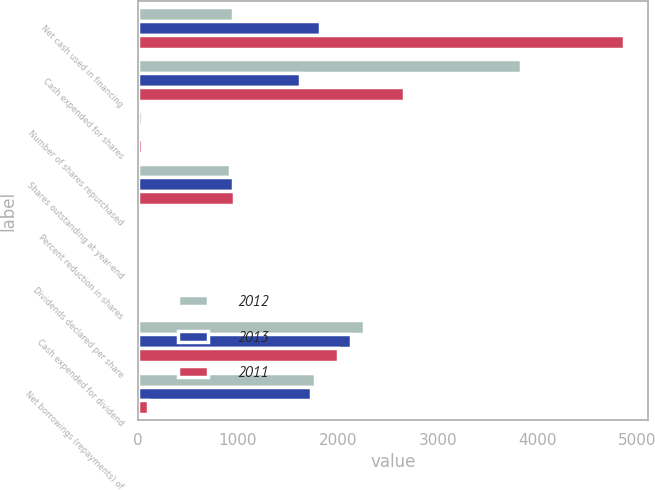<chart> <loc_0><loc_0><loc_500><loc_500><stacked_bar_chart><ecel><fcel>Net cash used in financing<fcel>Cash expended for shares<fcel>Number of shares repurchased<fcel>Shares outstanding at year-end<fcel>Percent reduction in shares<fcel>Dividends declared per share<fcel>Cash expended for dividend<fcel>Net borrowings (repayments) of<nl><fcel>2012<fcel>953<fcel>3838<fcel>43.2<fcel>923<fcel>3.1<fcel>2.48<fcel>2260<fcel>1775<nl><fcel>2013<fcel>1817<fcel>1621<fcel>21.8<fcel>953<fcel>1<fcel>2.28<fcel>2130<fcel>1729<nl><fcel>2011<fcel>4862<fcel>2665<fcel>38.7<fcel>963<fcel>2.8<fcel>2.08<fcel>1997<fcel>95<nl></chart> 